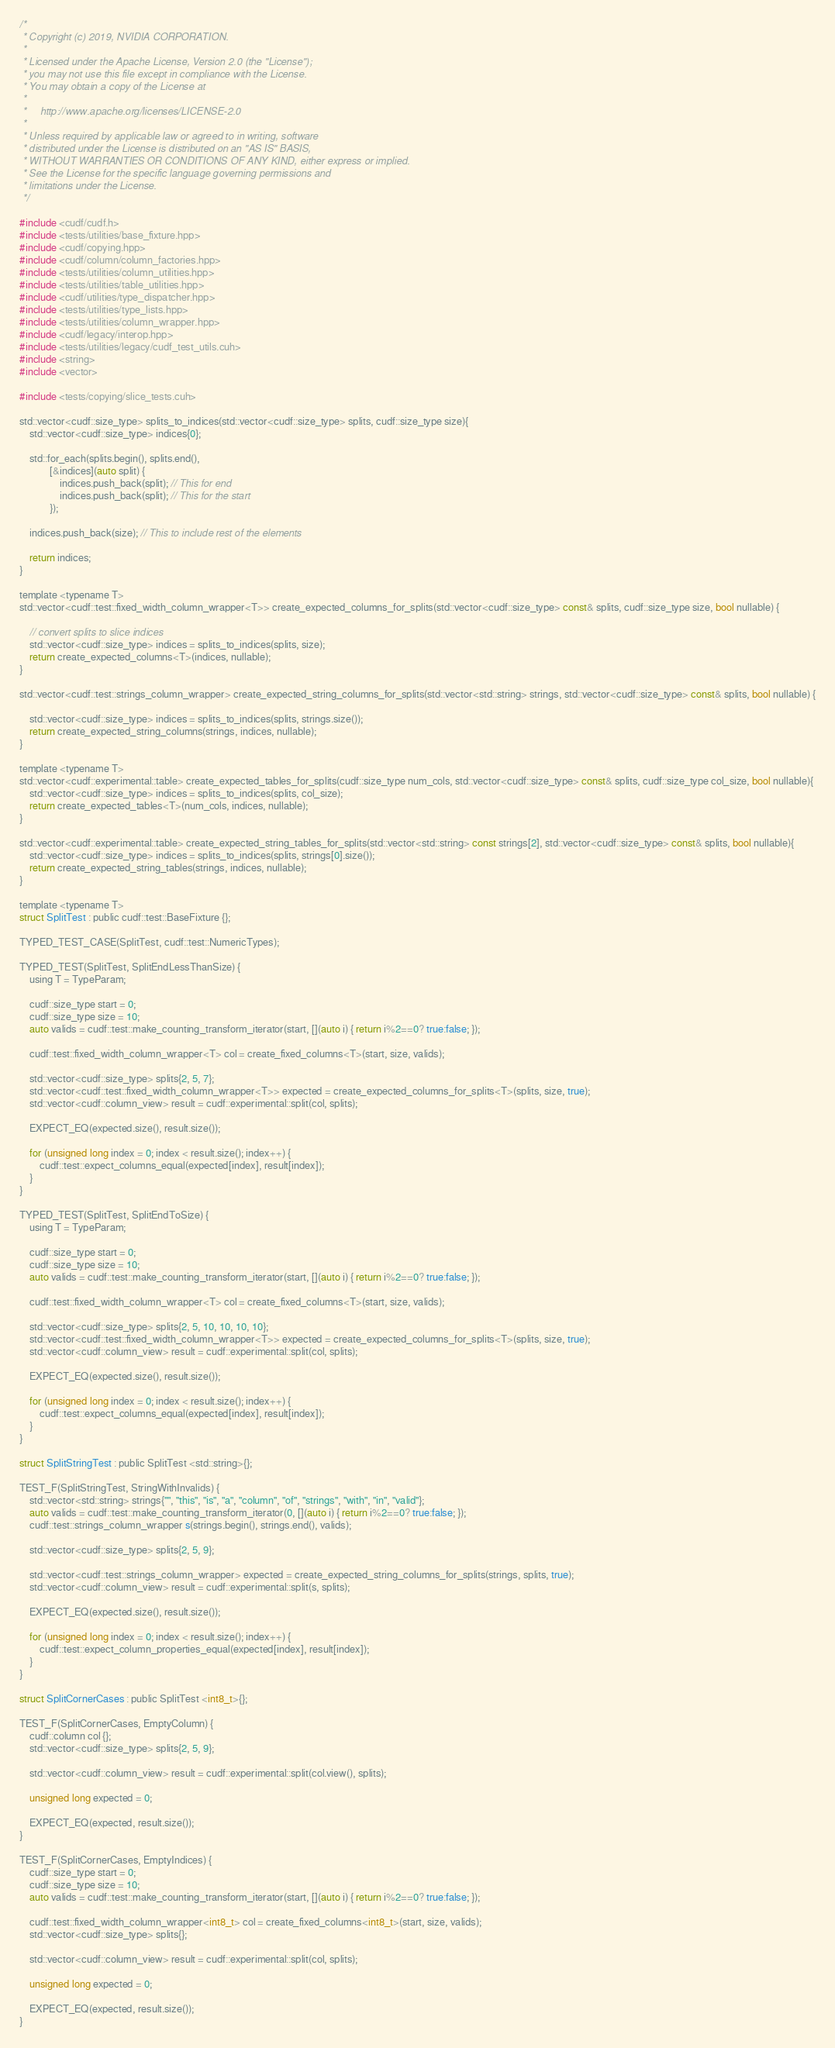Convert code to text. <code><loc_0><loc_0><loc_500><loc_500><_Cuda_>/*
 * Copyright (c) 2019, NVIDIA CORPORATION.
 *
 * Licensed under the Apache License, Version 2.0 (the "License");
 * you may not use this file except in compliance with the License.
 * You may obtain a copy of the License at
 *
 *     http://www.apache.org/licenses/LICENSE-2.0
 *
 * Unless required by applicable law or agreed to in writing, software
 * distributed under the License is distributed on an "AS IS" BASIS,
 * WITHOUT WARRANTIES OR CONDITIONS OF ANY KIND, either express or implied.
 * See the License for the specific language governing permissions and
 * limitations under the License.
 */

#include <cudf/cudf.h>
#include <tests/utilities/base_fixture.hpp>
#include <cudf/copying.hpp>
#include <cudf/column/column_factories.hpp>
#include <tests/utilities/column_utilities.hpp>
#include <tests/utilities/table_utilities.hpp>
#include <cudf/utilities/type_dispatcher.hpp>
#include <tests/utilities/type_lists.hpp>
#include <tests/utilities/column_wrapper.hpp>
#include <cudf/legacy/interop.hpp>
#include <tests/utilities/legacy/cudf_test_utils.cuh>
#include <string>
#include <vector>

#include <tests/copying/slice_tests.cuh>

std::vector<cudf::size_type> splits_to_indices(std::vector<cudf::size_type> splits, cudf::size_type size){
    std::vector<cudf::size_type> indices{0};

    std::for_each(splits.begin(), splits.end(),
            [&indices](auto split) {
                indices.push_back(split); // This for end
                indices.push_back(split); // This for the start
            });

    indices.push_back(size); // This to include rest of the elements

    return indices;
}

template <typename T>
std::vector<cudf::test::fixed_width_column_wrapper<T>> create_expected_columns_for_splits(std::vector<cudf::size_type> const& splits, cudf::size_type size, bool nullable) {

    // convert splits to slice indices
    std::vector<cudf::size_type> indices = splits_to_indices(splits, size);
    return create_expected_columns<T>(indices, nullable);
}

std::vector<cudf::test::strings_column_wrapper> create_expected_string_columns_for_splits(std::vector<std::string> strings, std::vector<cudf::size_type> const& splits, bool nullable) {

    std::vector<cudf::size_type> indices = splits_to_indices(splits, strings.size());
    return create_expected_string_columns(strings, indices, nullable);   
}

template <typename T>
std::vector<cudf::experimental::table> create_expected_tables_for_splits(cudf::size_type num_cols, std::vector<cudf::size_type> const& splits, cudf::size_type col_size, bool nullable){
    std::vector<cudf::size_type> indices = splits_to_indices(splits, col_size);    
    return create_expected_tables<T>(num_cols, indices, nullable);
}

std::vector<cudf::experimental::table> create_expected_string_tables_for_splits(std::vector<std::string> const strings[2], std::vector<cudf::size_type> const& splits, bool nullable){    
    std::vector<cudf::size_type> indices = splits_to_indices(splits, strings[0].size());    
    return create_expected_string_tables(strings, indices, nullable);
}

template <typename T>
struct SplitTest : public cudf::test::BaseFixture {};

TYPED_TEST_CASE(SplitTest, cudf::test::NumericTypes);

TYPED_TEST(SplitTest, SplitEndLessThanSize) {
    using T = TypeParam;

    cudf::size_type start = 0;
    cudf::size_type size = 10;
    auto valids = cudf::test::make_counting_transform_iterator(start, [](auto i) { return i%2==0? true:false; });

    cudf::test::fixed_width_column_wrapper<T> col = create_fixed_columns<T>(start, size, valids);

    std::vector<cudf::size_type> splits{2, 5, 7};
    std::vector<cudf::test::fixed_width_column_wrapper<T>> expected = create_expected_columns_for_splits<T>(splits, size, true);
    std::vector<cudf::column_view> result = cudf::experimental::split(col, splits);

    EXPECT_EQ(expected.size(), result.size());

    for (unsigned long index = 0; index < result.size(); index++) {
        cudf::test::expect_columns_equal(expected[index], result[index]);
    }
}

TYPED_TEST(SplitTest, SplitEndToSize) {
    using T = TypeParam;

    cudf::size_type start = 0;
    cudf::size_type size = 10;
    auto valids = cudf::test::make_counting_transform_iterator(start, [](auto i) { return i%2==0? true:false; });

    cudf::test::fixed_width_column_wrapper<T> col = create_fixed_columns<T>(start, size, valids);

    std::vector<cudf::size_type> splits{2, 5, 10, 10, 10, 10};
    std::vector<cudf::test::fixed_width_column_wrapper<T>> expected = create_expected_columns_for_splits<T>(splits, size, true);
    std::vector<cudf::column_view> result = cudf::experimental::split(col, splits);

    EXPECT_EQ(expected.size(), result.size());

    for (unsigned long index = 0; index < result.size(); index++) {
        cudf::test::expect_columns_equal(expected[index], result[index]);
    }
}

struct SplitStringTest : public SplitTest <std::string>{};

TEST_F(SplitStringTest, StringWithInvalids) {
    std::vector<std::string> strings{"", "this", "is", "a", "column", "of", "strings", "with", "in", "valid"};
    auto valids = cudf::test::make_counting_transform_iterator(0, [](auto i) { return i%2==0? true:false; });
    cudf::test::strings_column_wrapper s(strings.begin(), strings.end(), valids);

    std::vector<cudf::size_type> splits{2, 5, 9};

    std::vector<cudf::test::strings_column_wrapper> expected = create_expected_string_columns_for_splits(strings, splits, true);
    std::vector<cudf::column_view> result = cudf::experimental::split(s, splits);

    EXPECT_EQ(expected.size(), result.size());

    for (unsigned long index = 0; index < result.size(); index++) {
        cudf::test::expect_column_properties_equal(expected[index], result[index]);
    }
}

struct SplitCornerCases : public SplitTest <int8_t>{};

TEST_F(SplitCornerCases, EmptyColumn) {
    cudf::column col {};
    std::vector<cudf::size_type> splits{2, 5, 9};

    std::vector<cudf::column_view> result = cudf::experimental::split(col.view(), splits);

    unsigned long expected = 0;

    EXPECT_EQ(expected, result.size());
}

TEST_F(SplitCornerCases, EmptyIndices) {
    cudf::size_type start = 0;
    cudf::size_type size = 10;
    auto valids = cudf::test::make_counting_transform_iterator(start, [](auto i) { return i%2==0? true:false; });

    cudf::test::fixed_width_column_wrapper<int8_t> col = create_fixed_columns<int8_t>(start, size, valids);
    std::vector<cudf::size_type> splits{};

    std::vector<cudf::column_view> result = cudf::experimental::split(col, splits);

    unsigned long expected = 0;

    EXPECT_EQ(expected, result.size());
}
</code> 